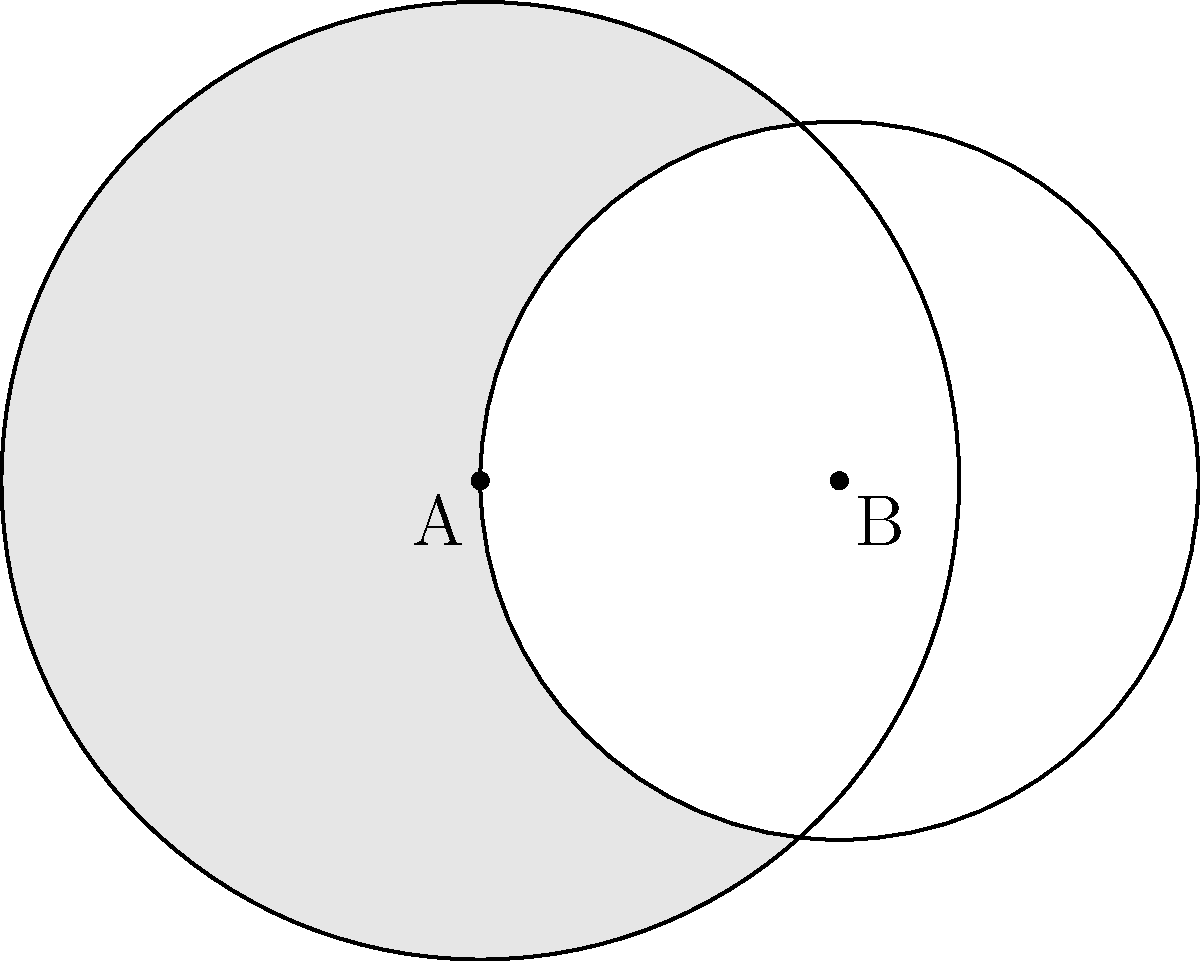Your child's math teacher has assigned a challenging problem to test their problem-solving skills. The diagram shows two overlapping circles with centers A and B. Circle A has a radius of 2 units, and circle B has a radius of 1.5 units. The distance between their centers is 1.5 units. Calculate the area of the shaded region to the nearest hundredth. How will you guide your child to solve this problem systematically? Let's guide your child through this problem step-by-step:

1) First, we need to find the area of the shaded region, which is the difference between the area of circle A and the area of the overlap.

2) Area of circle A: 
   $$A_A = \pi r_A^2 = \pi (2)^2 = 4\pi$$

3) To find the area of the overlap, we need to use the formula for the area of intersection of two circles:
   $$A_{overlap} = r_1^2 \arccos(\frac{d^2 + r_1^2 - r_2^2}{2dr_1}) + r_2^2 \arccos(\frac{d^2 + r_2^2 - r_1^2}{2dr_2}) - \frac{1}{2}\sqrt{(-d+r_1+r_2)(d+r_1-r_2)(d-r_1+r_2)(d+r_1+r_2)}$$

   Where $r_1 = 2$, $r_2 = 1.5$, and $d = 1.5$

4) Substituting these values:
   $$A_{overlap} = 4 \arccos(\frac{1.5^2 + 2^2 - 1.5^2}{2(1.5)(2)}) + 2.25 \arccos(\frac{1.5^2 + 1.5^2 - 2^2}{2(1.5)(1.5)}) - \frac{1}{2}\sqrt{(-1.5+2+1.5)(1.5+2-1.5)(1.5-2+1.5)(1.5+2+1.5)}$$

5) Simplifying:
   $$A_{overlap} = 4 \arccos(0.75) + 2.25 \arccos(0.5) - \frac{1}{2}\sqrt{2 \cdot 2 \cdot 1 \cdot 5} = 4 \cdot 0.7227 + 2.25 \cdot 1.0472 - \frac{1}{2}\sqrt{20}$$

6) Calculate:
   $$A_{overlap} \approx 2.8908 + 2.3562 - 2.2361 \approx 3.0109$$

7) The shaded area is the difference:
   $$A_{shaded} = A_A - A_{overlap} = 4\pi - 3.0109 \approx 9.5664$$

8) Rounding to the nearest hundredth:
   $$A_{shaded} \approx 9.57$$

Encourage your child to follow each step carefully, showing all work, and to double-check their calculations.
Answer: 9.57 square units 